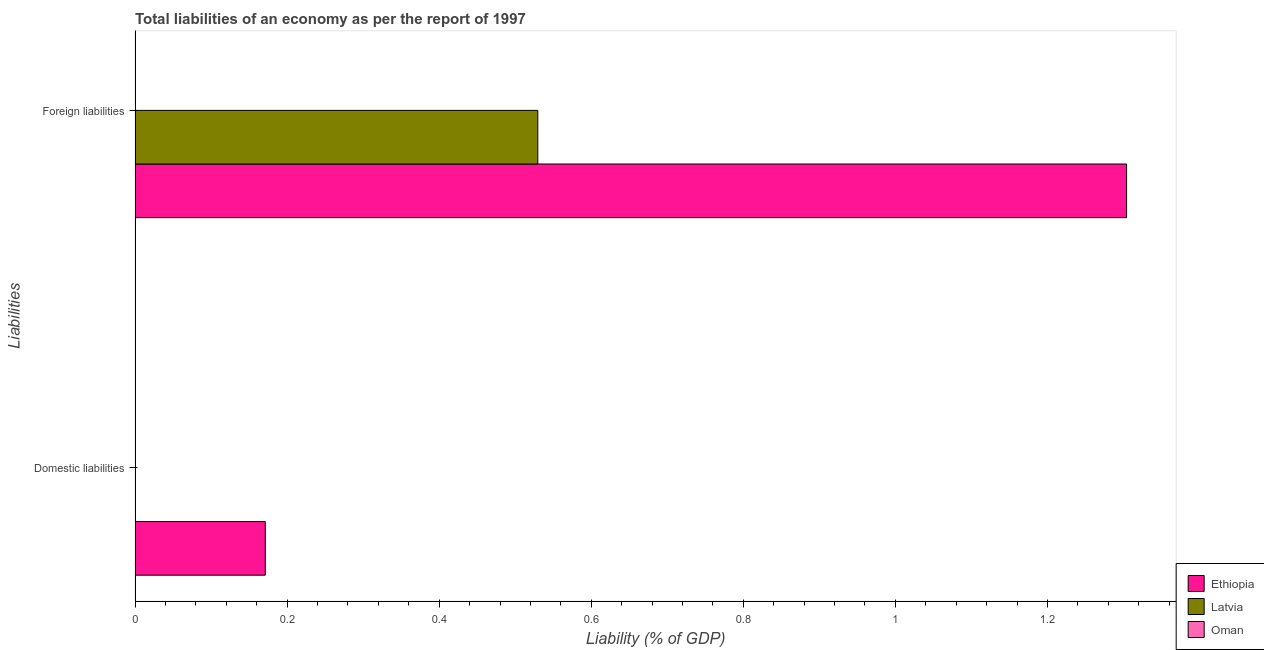Are the number of bars on each tick of the Y-axis equal?
Your answer should be compact. No. What is the label of the 1st group of bars from the top?
Provide a short and direct response. Foreign liabilities. What is the incurrence of foreign liabilities in Latvia?
Your answer should be compact. 0.53. Across all countries, what is the maximum incurrence of foreign liabilities?
Your answer should be compact. 1.3. In which country was the incurrence of foreign liabilities maximum?
Your answer should be very brief. Ethiopia. What is the total incurrence of domestic liabilities in the graph?
Provide a succinct answer. 0.17. What is the difference between the incurrence of foreign liabilities in Ethiopia and that in Latvia?
Your answer should be very brief. 0.77. What is the difference between the incurrence of domestic liabilities in Oman and the incurrence of foreign liabilities in Ethiopia?
Offer a very short reply. -1.3. What is the average incurrence of foreign liabilities per country?
Your response must be concise. 0.61. What is the difference between the incurrence of foreign liabilities and incurrence of domestic liabilities in Ethiopia?
Your answer should be compact. 1.13. In how many countries, is the incurrence of domestic liabilities greater than 0.08 %?
Keep it short and to the point. 1. Are all the bars in the graph horizontal?
Keep it short and to the point. Yes. How many countries are there in the graph?
Offer a very short reply. 3. What is the difference between two consecutive major ticks on the X-axis?
Your answer should be very brief. 0.2. Are the values on the major ticks of X-axis written in scientific E-notation?
Offer a terse response. No. Does the graph contain grids?
Provide a succinct answer. No. How are the legend labels stacked?
Offer a terse response. Vertical. What is the title of the graph?
Provide a succinct answer. Total liabilities of an economy as per the report of 1997. Does "Equatorial Guinea" appear as one of the legend labels in the graph?
Your answer should be very brief. No. What is the label or title of the X-axis?
Your response must be concise. Liability (% of GDP). What is the label or title of the Y-axis?
Your answer should be very brief. Liabilities. What is the Liability (% of GDP) in Ethiopia in Domestic liabilities?
Keep it short and to the point. 0.17. What is the Liability (% of GDP) in Oman in Domestic liabilities?
Make the answer very short. 0. What is the Liability (% of GDP) in Ethiopia in Foreign liabilities?
Your answer should be compact. 1.3. What is the Liability (% of GDP) in Latvia in Foreign liabilities?
Offer a terse response. 0.53. What is the Liability (% of GDP) of Oman in Foreign liabilities?
Offer a terse response. 0. Across all Liabilities, what is the maximum Liability (% of GDP) in Ethiopia?
Make the answer very short. 1.3. Across all Liabilities, what is the maximum Liability (% of GDP) of Latvia?
Offer a terse response. 0.53. Across all Liabilities, what is the minimum Liability (% of GDP) in Ethiopia?
Provide a short and direct response. 0.17. Across all Liabilities, what is the minimum Liability (% of GDP) in Latvia?
Give a very brief answer. 0. What is the total Liability (% of GDP) of Ethiopia in the graph?
Offer a terse response. 1.48. What is the total Liability (% of GDP) of Latvia in the graph?
Your answer should be compact. 0.53. What is the difference between the Liability (% of GDP) in Ethiopia in Domestic liabilities and that in Foreign liabilities?
Provide a succinct answer. -1.13. What is the difference between the Liability (% of GDP) of Ethiopia in Domestic liabilities and the Liability (% of GDP) of Latvia in Foreign liabilities?
Your answer should be compact. -0.36. What is the average Liability (% of GDP) in Ethiopia per Liabilities?
Your response must be concise. 0.74. What is the average Liability (% of GDP) of Latvia per Liabilities?
Keep it short and to the point. 0.26. What is the difference between the Liability (% of GDP) in Ethiopia and Liability (% of GDP) in Latvia in Foreign liabilities?
Offer a terse response. 0.77. What is the ratio of the Liability (% of GDP) of Ethiopia in Domestic liabilities to that in Foreign liabilities?
Make the answer very short. 0.13. What is the difference between the highest and the second highest Liability (% of GDP) of Ethiopia?
Your answer should be very brief. 1.13. What is the difference between the highest and the lowest Liability (% of GDP) in Ethiopia?
Give a very brief answer. 1.13. What is the difference between the highest and the lowest Liability (% of GDP) in Latvia?
Offer a terse response. 0.53. 